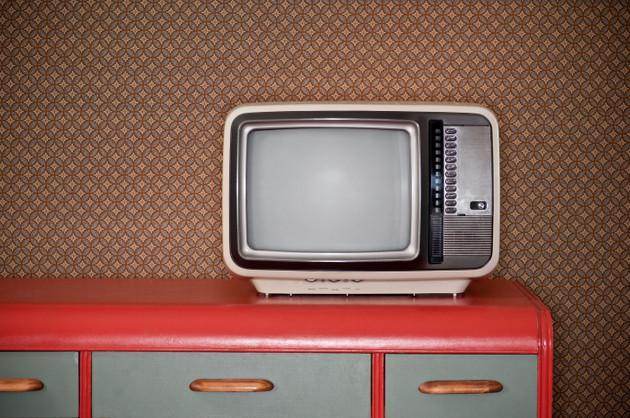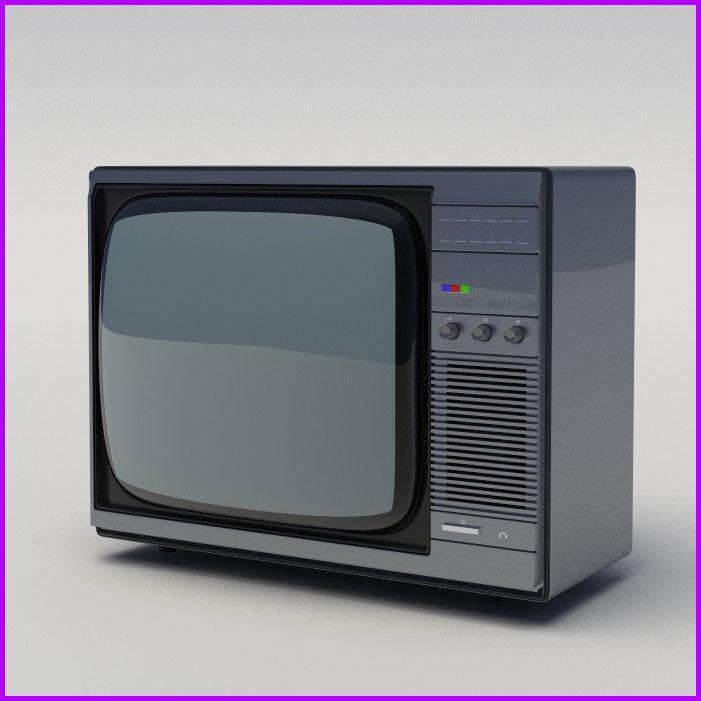The first image is the image on the left, the second image is the image on the right. For the images displayed, is the sentence "One TV is sitting outside with grass and trees in the background." factually correct? Answer yes or no. No. The first image is the image on the left, the second image is the image on the right. Examine the images to the left and right. Is the description "One TV has three small knobs in a horizontal row at the bottom right and two black rectangles arranged one over the other on the upper right." accurate? Answer yes or no. No. 